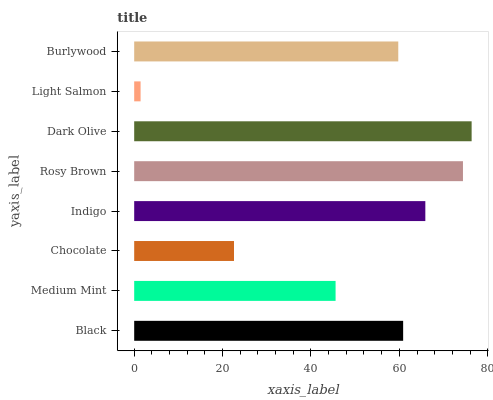Is Light Salmon the minimum?
Answer yes or no. Yes. Is Dark Olive the maximum?
Answer yes or no. Yes. Is Medium Mint the minimum?
Answer yes or no. No. Is Medium Mint the maximum?
Answer yes or no. No. Is Black greater than Medium Mint?
Answer yes or no. Yes. Is Medium Mint less than Black?
Answer yes or no. Yes. Is Medium Mint greater than Black?
Answer yes or no. No. Is Black less than Medium Mint?
Answer yes or no. No. Is Black the high median?
Answer yes or no. Yes. Is Burlywood the low median?
Answer yes or no. Yes. Is Light Salmon the high median?
Answer yes or no. No. Is Black the low median?
Answer yes or no. No. 